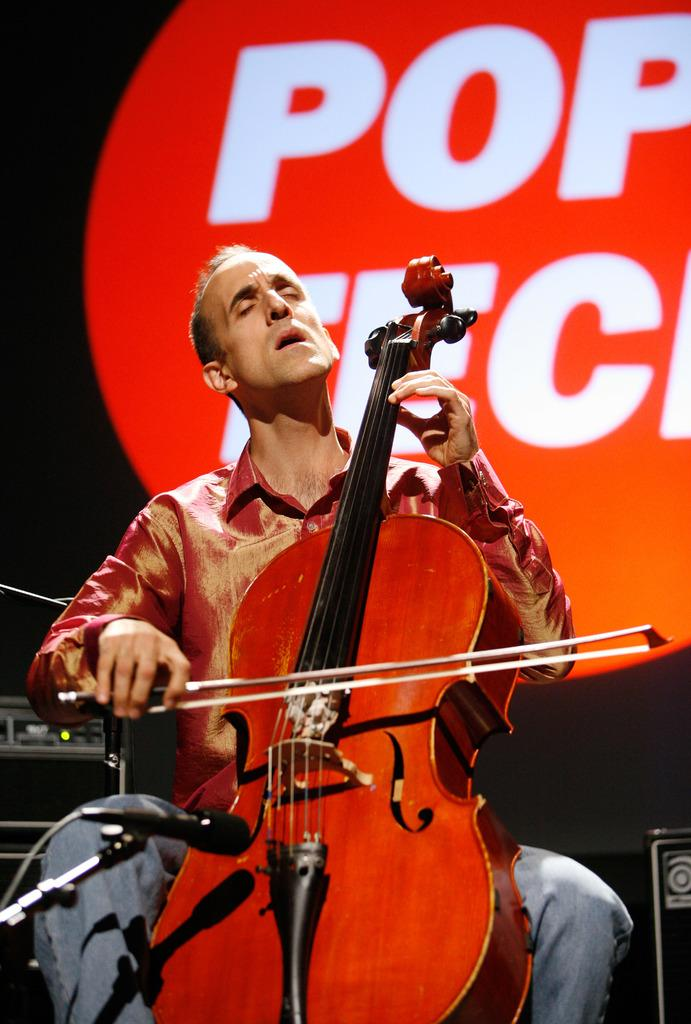What is the man in the image doing? The man is sitting on a chair and playing a red violin. What is the man wearing? The man is wearing a red shirt. What is the man positioned in front of? The man is in front of a microphone. What device is present in the image? There is a device present, but its specific type is not mentioned. What is located beside the man? There is a speaker beside the man. What is the color of the background in the image? The background has a red color. Can you see any balloons floating in the background of the image? There are no balloons visible in the image; the background has a red color. Is there a lake visible in the image? There is no lake present in the image; the man is sitting in front of a microphone and playing a red violin. 